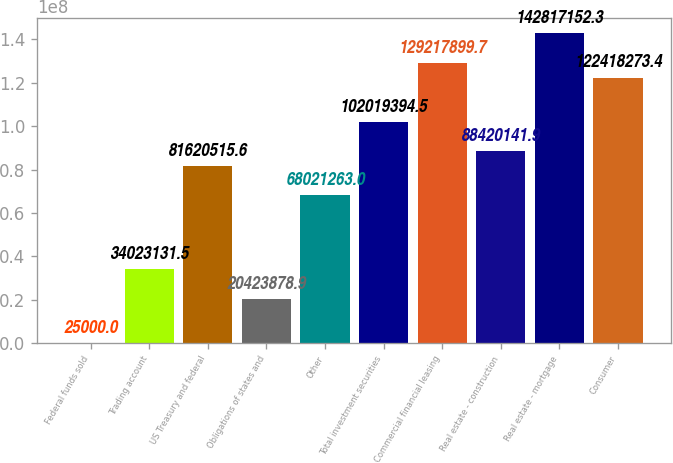Convert chart. <chart><loc_0><loc_0><loc_500><loc_500><bar_chart><fcel>Federal funds sold<fcel>Trading account<fcel>US Treasury and federal<fcel>Obligations of states and<fcel>Other<fcel>Total investment securities<fcel>Commercial financial leasing<fcel>Real estate - construction<fcel>Real estate - mortgage<fcel>Consumer<nl><fcel>25000<fcel>3.40231e+07<fcel>8.16205e+07<fcel>2.04239e+07<fcel>6.80213e+07<fcel>1.02019e+08<fcel>1.29218e+08<fcel>8.84201e+07<fcel>1.42817e+08<fcel>1.22418e+08<nl></chart> 